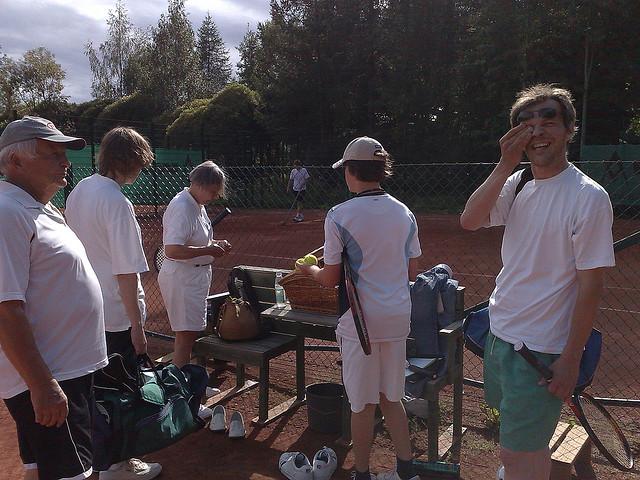What are they doing?
Be succinct. Playing tennis. How many dressed in white?
Be succinct. 6. What's the odd color out in terms of shorts?
Quick response, please. Green. What are the people doing?
Quick response, please. Tennis. 